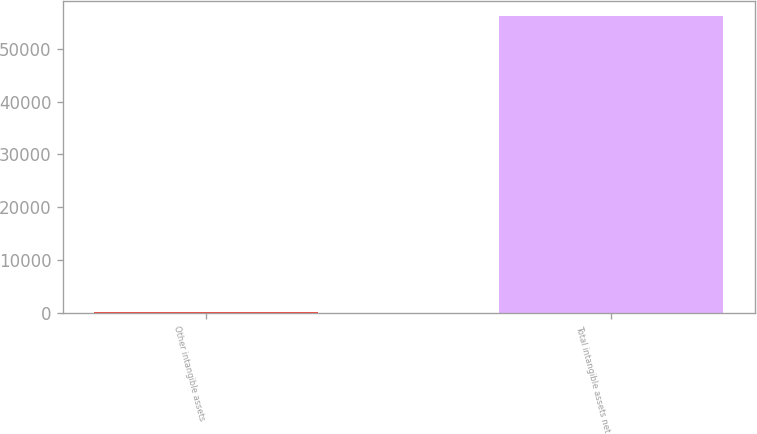Convert chart to OTSL. <chart><loc_0><loc_0><loc_500><loc_500><bar_chart><fcel>Other intangible assets<fcel>Total intangible assets net<nl><fcel>37<fcel>56224<nl></chart> 